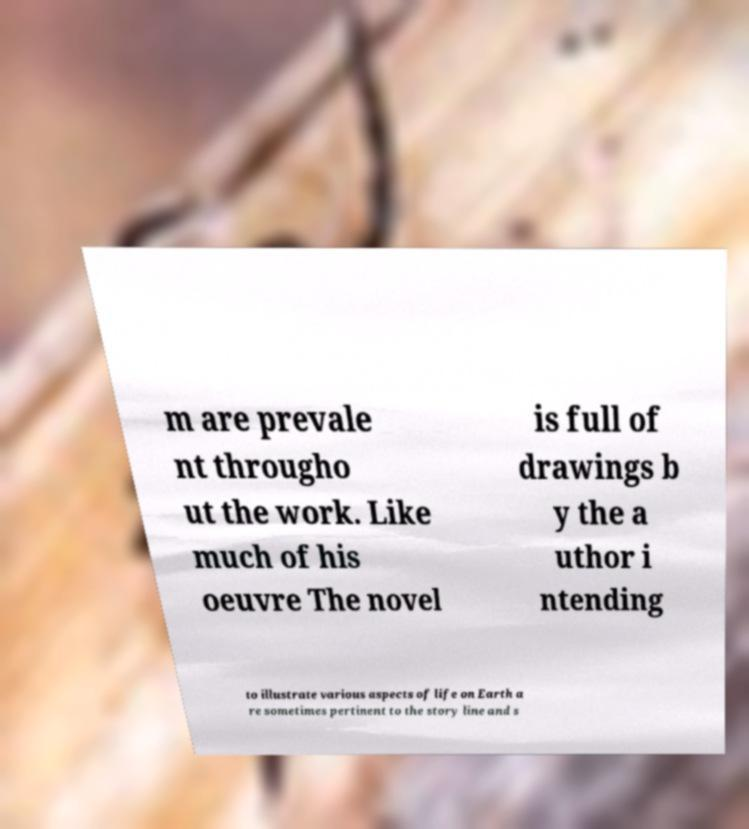There's text embedded in this image that I need extracted. Can you transcribe it verbatim? m are prevale nt througho ut the work. Like much of his oeuvre The novel is full of drawings b y the a uthor i ntending to illustrate various aspects of life on Earth a re sometimes pertinent to the story line and s 